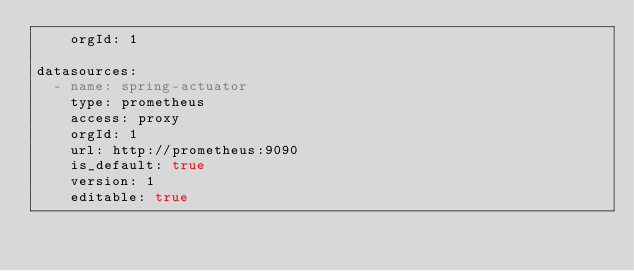Convert code to text. <code><loc_0><loc_0><loc_500><loc_500><_YAML_>    orgId: 1

datasources:
  - name: spring-actuator
    type: prometheus
    access: proxy
    orgId: 1
    url: http://prometheus:9090
    is_default: true
    version: 1
    editable: true</code> 